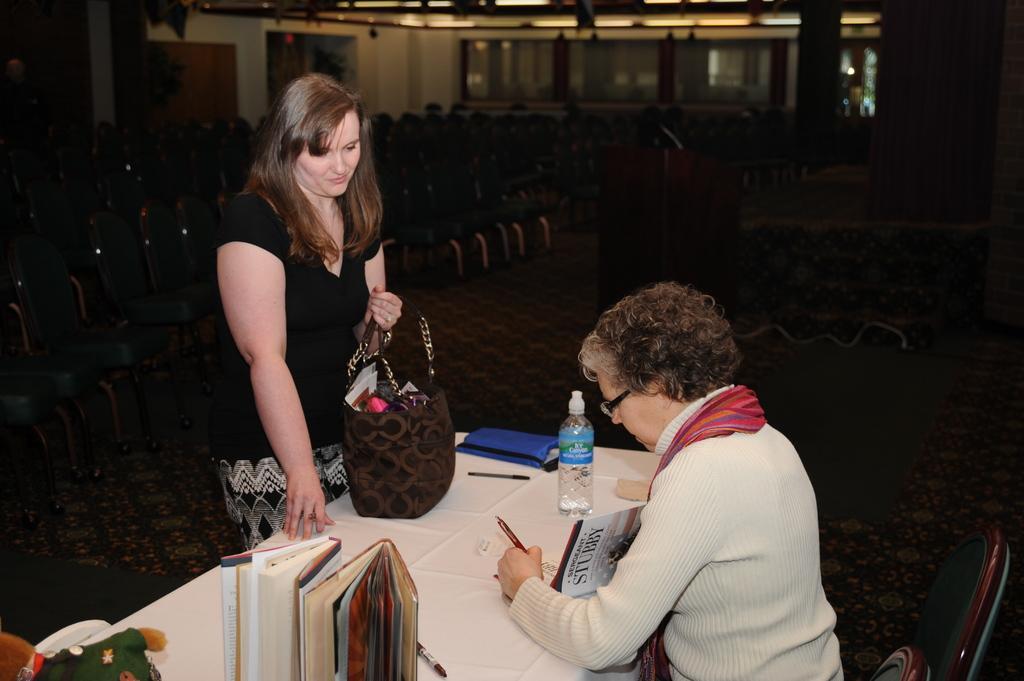How would you summarize this image in a sentence or two? A lady with black dress is standing in front of the table. She kept her bag on the table. And there is another lady sitting on the chair holding the book in her hand. On the table there are some books, water bottle. In the background there are some chairs. To the right side there is a podium. 